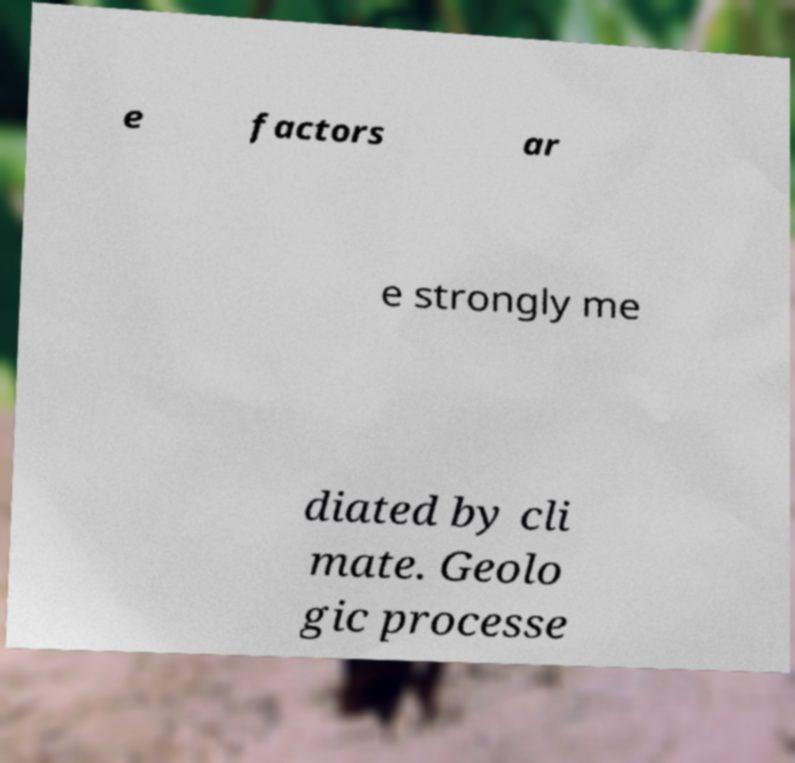Could you extract and type out the text from this image? e factors ar e strongly me diated by cli mate. Geolo gic processe 